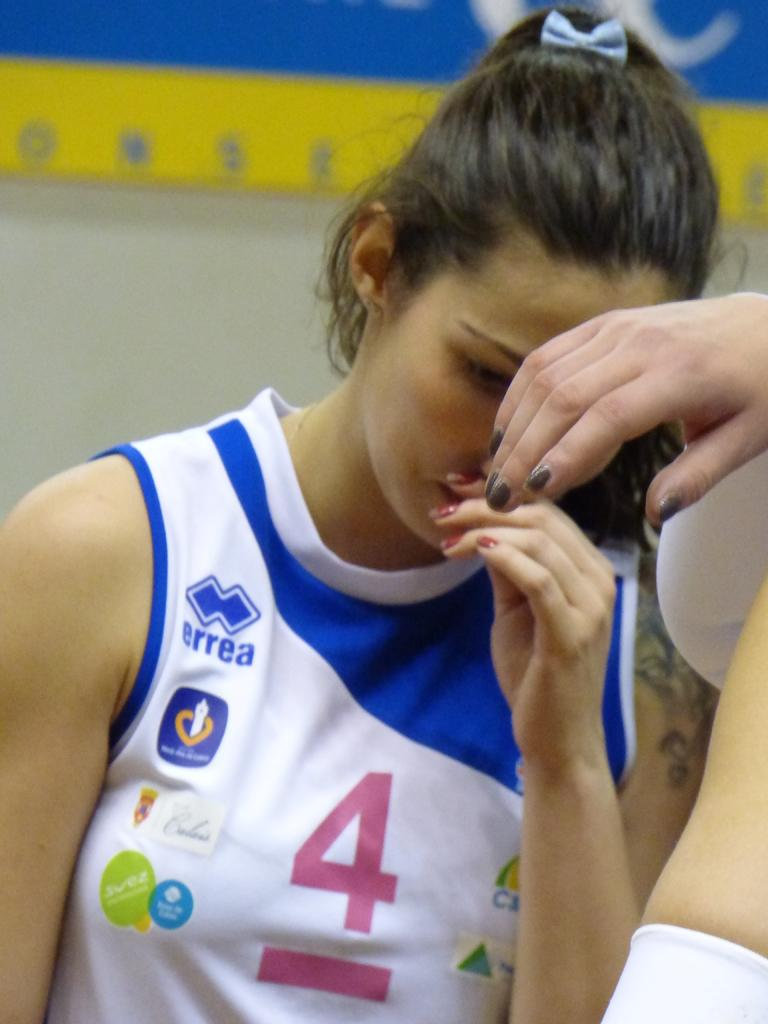What is on the right side of the image? There is a human hand and body on the right side of the image. Who is present in the image? A woman is present in the image. What can be seen on the woman's arm? The woman has a tattoo on her arm. How would you describe the background of the image? The background of the image has a blurred view. What can be found in the image besides the woman? There is a banner in the image. How many dimes can be seen on the woman's head in the image? There are no dimes present on the woman's head in the image. What type of wheel is visible in the image? There is no wheel visible in the image. 